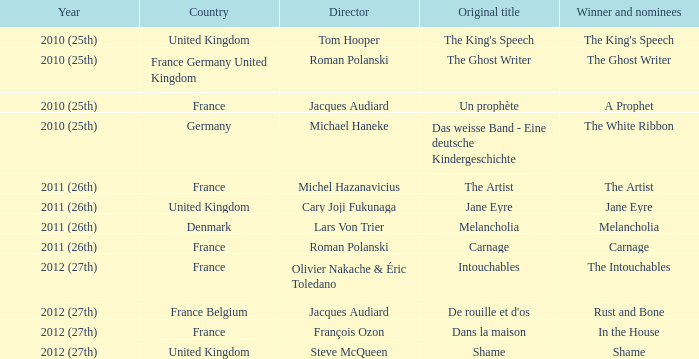Who was the director of the king's speech? Tom Hooper. 